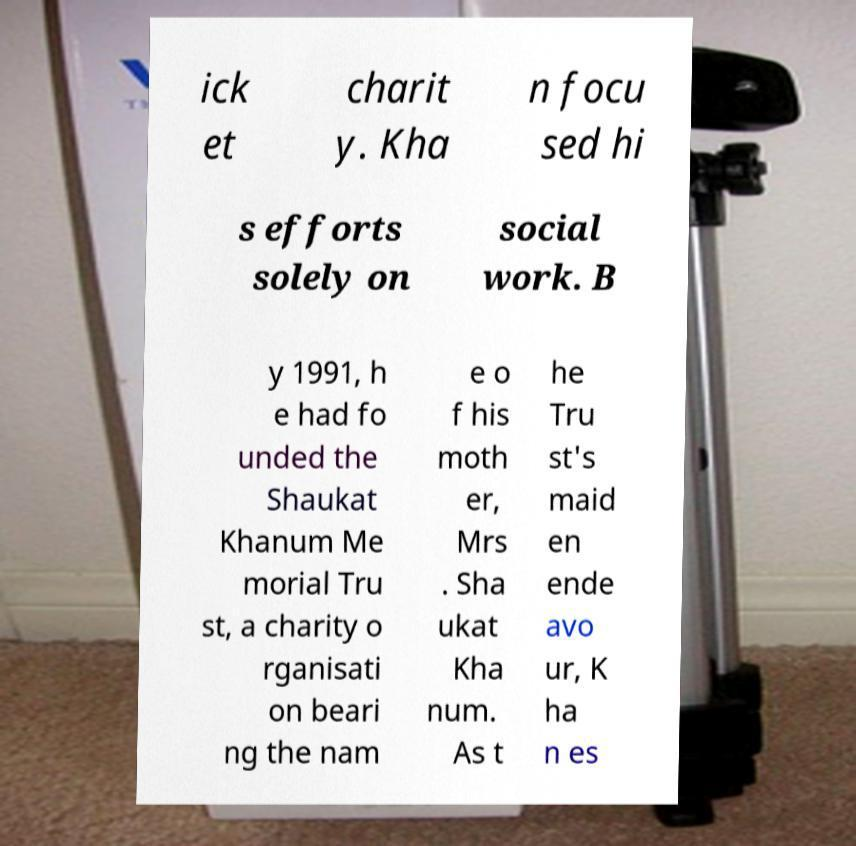I need the written content from this picture converted into text. Can you do that? ick et charit y. Kha n focu sed hi s efforts solely on social work. B y 1991, h e had fo unded the Shaukat Khanum Me morial Tru st, a charity o rganisati on beari ng the nam e o f his moth er, Mrs . Sha ukat Kha num. As t he Tru st's maid en ende avo ur, K ha n es 